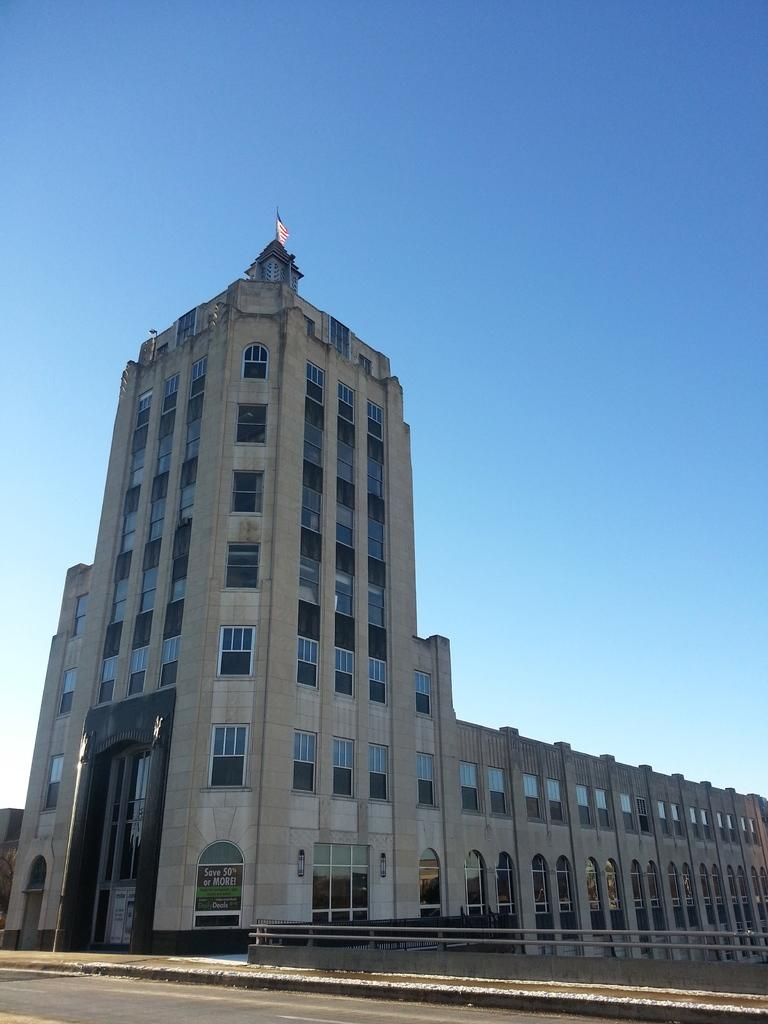What is the main structure visible in the image? There is a building in the image. What is located at the top of the building? The top of the building has a flag. How many thumbs can be seen on the coach in the image? There is no coach or thumb present in the image. What does the building need to improve its appearance in the image? The image does not provide any information about the building's appearance or what it might need to improve it. 